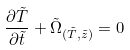<formula> <loc_0><loc_0><loc_500><loc_500>\frac { \partial \tilde { T } } { \partial \tilde { t } } + \tilde { \Omega } _ { ( \tilde { T } , \tilde { z } ) } = 0</formula> 